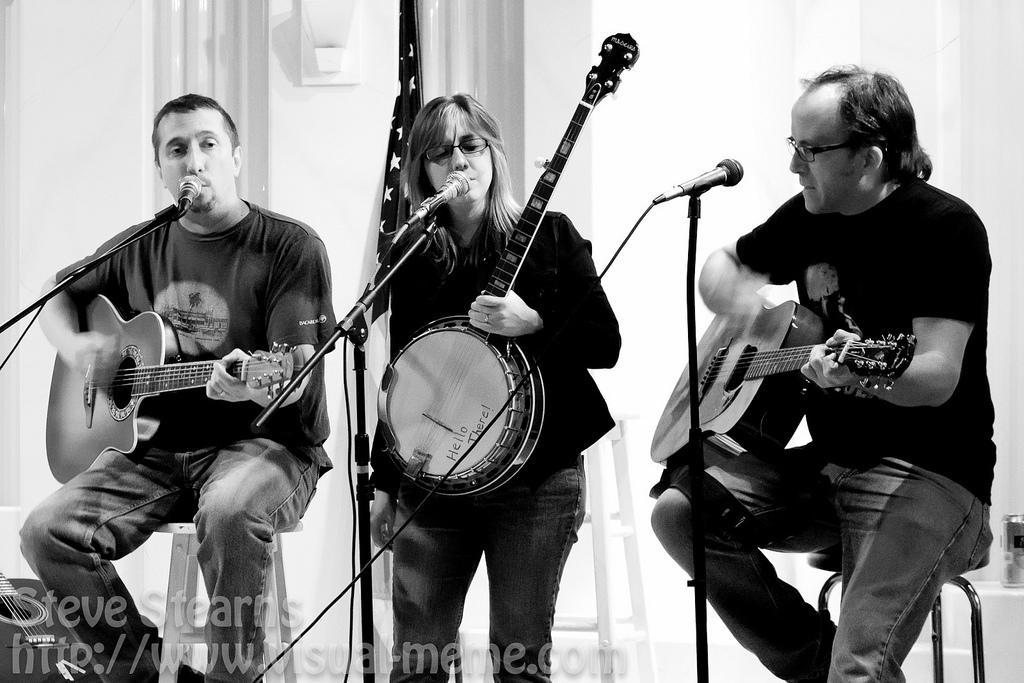How would you summarize this image in a sentence or two? In this picture we can see three people, two men are seated on the chairs, and a woman is standing, they are playing guitars in front of the microphones. 